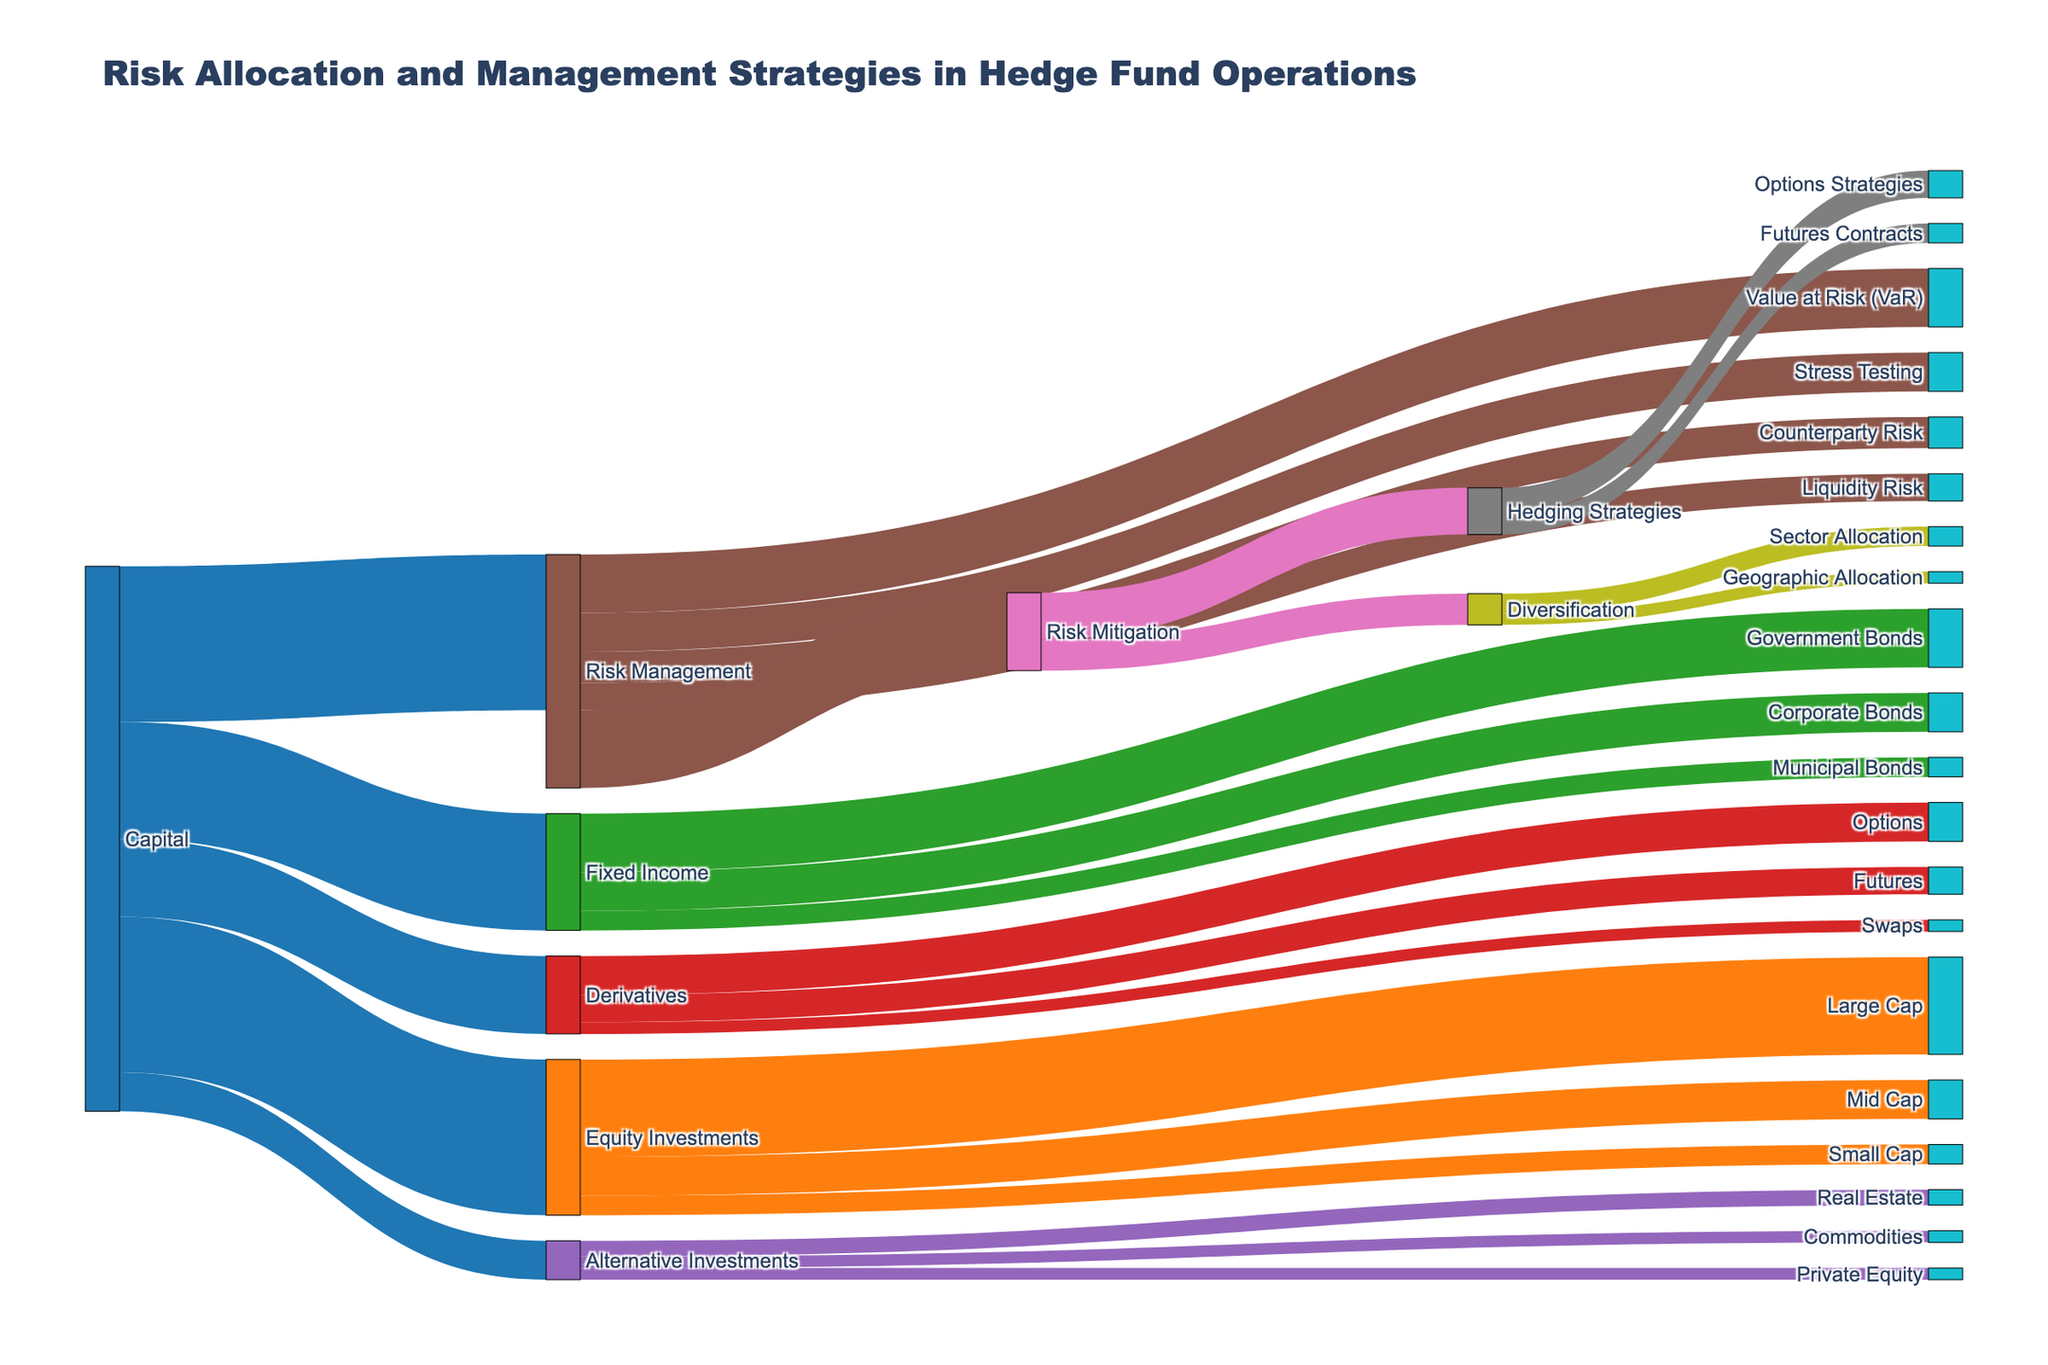What is the total capital allocated to Equity Investments? By looking at the flow from Capital to Equity Investments, we can see the value is 40.
Answer: 40 Which category under Equity Investments receives the highest allocation? Under Equity Investments, Large Cap has the highest allocation value, which is 25.
Answer: Large Cap How much capital is allocated to Alternative Investments? The flow from Capital to Alternative Investments shows a value of 10.
Answer: 10 What is the combined value of Mid Cap and Small Cap under Equity Investments? The values for Mid Cap and Small Cap are 10 and 5, respectively. Adding them gives 10+5=15.
Answer: 15 Compare the allocation to Fixed Income and Derivatives. Which one is higher and by how much? Fixed Income is allocated 30, while Derivatives are allocated 20. The difference is 30-20=10.
Answer: Fixed Income by 10 How much Risk Management allocation is devoted to Risk Mitigation? From Risk Management to Risk Mitigation, the value is 20.
Answer: 20 What is the least allocated category under Risk Management? Liquidity Risk has the lowest allocation within Risk Management, with a value of 7.
Answer: Liquidity Risk What is the total allocation for all types of Risk Management techniques combined? The values for VaR, Stress Testing, Counterparty Risk, and Liquidity Risk are 15, 10, 8, and 7, respectively. Adding these values gives 15+10+8+7=40.
Answer: 40 Identify the main components of Hedging Strategies and their respective values. Hedging Strategies consist of Options Strategies and Futures Contracts with values of 7 and 5, respectively.
Answer: Options Strategies: 7, Futures Contracts: 5 If Capital allocates 40 to Risk Management, how much is still allocated to other categories? The total capital is 100 (40 + 30 + 20 + 10). Allocating 40 to Risk Management means 100-40=60 is allocated to other categories.
Answer: 60 